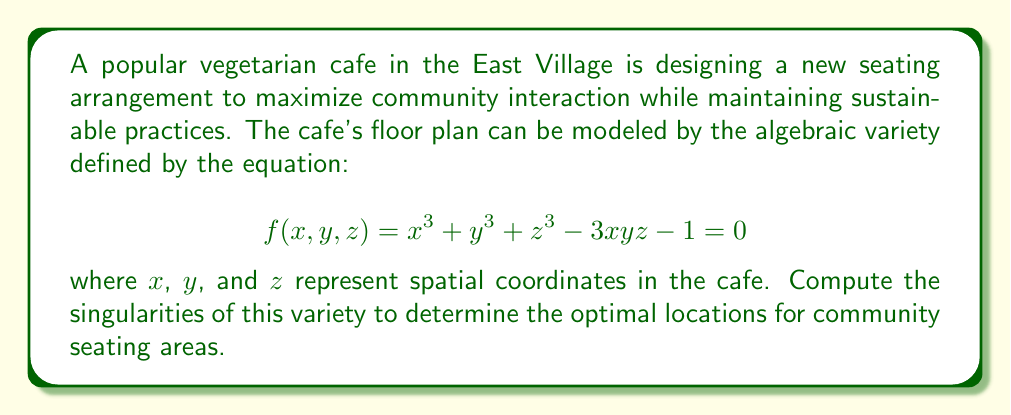Provide a solution to this math problem. To find the singularities of the algebraic variety, we need to follow these steps:

1) Calculate the partial derivatives of $f(x,y,z)$ with respect to $x$, $y$, and $z$:

   $\frac{\partial f}{\partial x} = 3x^2 - 3yz$
   $\frac{\partial f}{\partial y} = 3y^2 - 3xz$
   $\frac{\partial f}{\partial z} = 3z^2 - 3xy$

2) Set each partial derivative equal to zero:

   $3x^2 - 3yz = 0$
   $3y^2 - 3xz = 0$
   $3z^2 - 3xy = 0$

3) Solve this system of equations along with the original equation:

   $x^3 + y^3 + z^3 - 3xyz - 1 = 0$

4) From the partial derivatives, we can deduce:

   $x^2 = yz$
   $y^2 = xz$
   $z^2 = xy$

5) Multiplying these equations:

   $x^2y^2z^2 = (yz)(xz)(xy) = x^2y^2z^2$

   This is always true, so it doesn't give us new information.

6) Substituting these into the original equation:

   $x(yz) + y(xz) + z(xy) - 3xyz - 1 = 0$
   $3xyz - 3xyz - 1 = 0$
   $-1 = 0$

7) This is a contradiction, which means there are no points that satisfy all these equations simultaneously.

Therefore, the variety has no singular points.
Answer: No singularities 